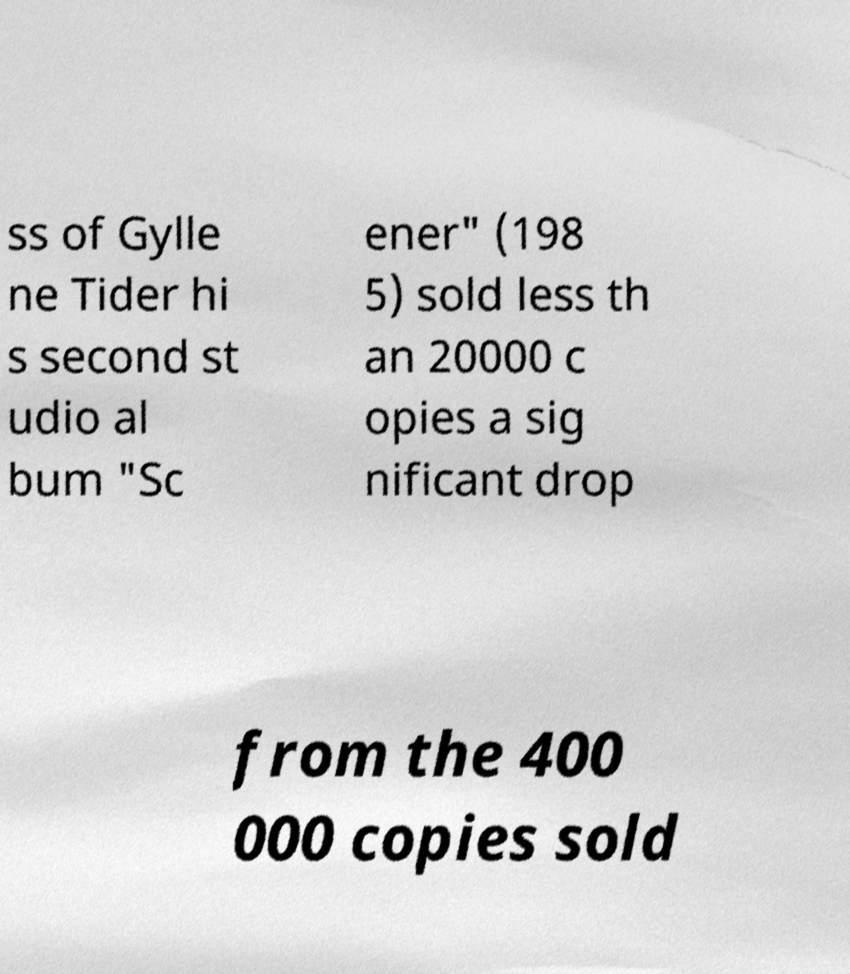For documentation purposes, I need the text within this image transcribed. Could you provide that? ss of Gylle ne Tider hi s second st udio al bum "Sc ener" (198 5) sold less th an 20000 c opies a sig nificant drop from the 400 000 copies sold 